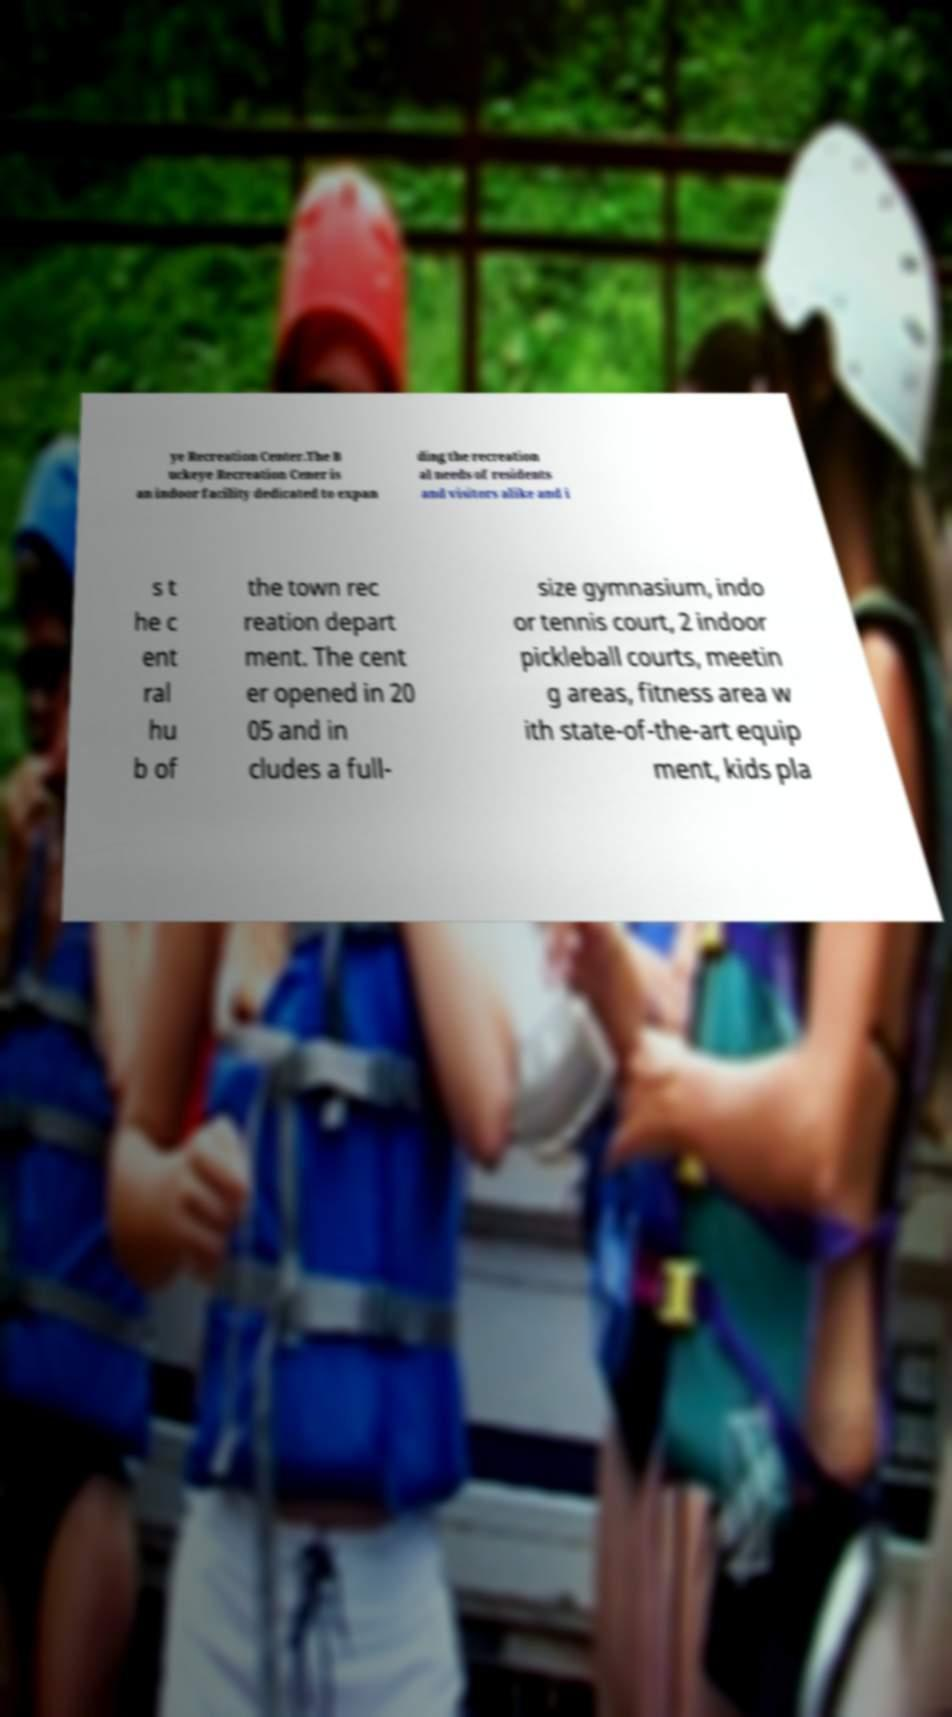For documentation purposes, I need the text within this image transcribed. Could you provide that? ye Recreation Center.The B uckeye Recreation Cener is an indoor facility dedicated to expan ding the recreation al needs of residents and visitors alike and i s t he c ent ral hu b of the town rec reation depart ment. The cent er opened in 20 05 and in cludes a full- size gymnasium, indo or tennis court, 2 indoor pickleball courts, meetin g areas, fitness area w ith state-of-the-art equip ment, kids pla 